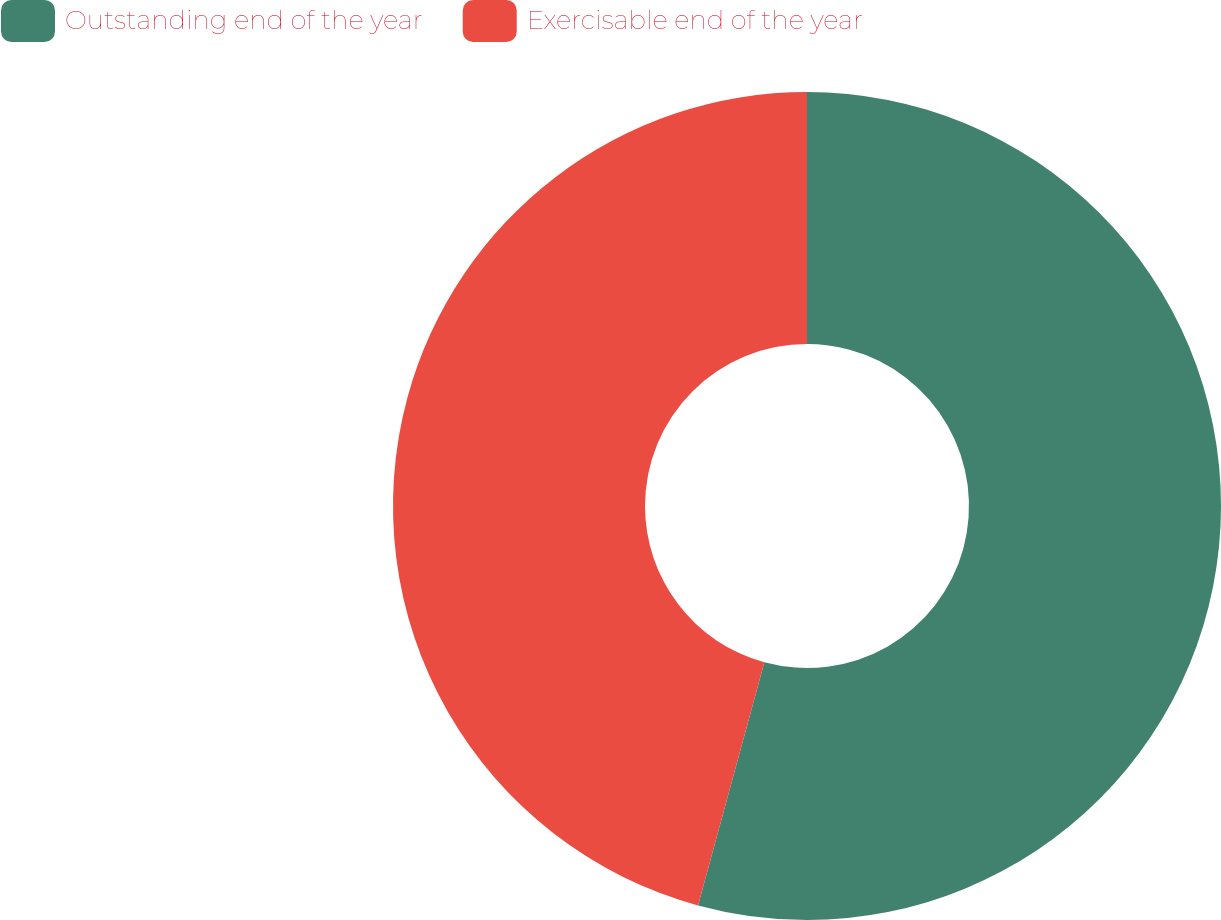Convert chart to OTSL. <chart><loc_0><loc_0><loc_500><loc_500><pie_chart><fcel>Outstanding end of the year<fcel>Exercisable end of the year<nl><fcel>54.24%<fcel>45.76%<nl></chart> 